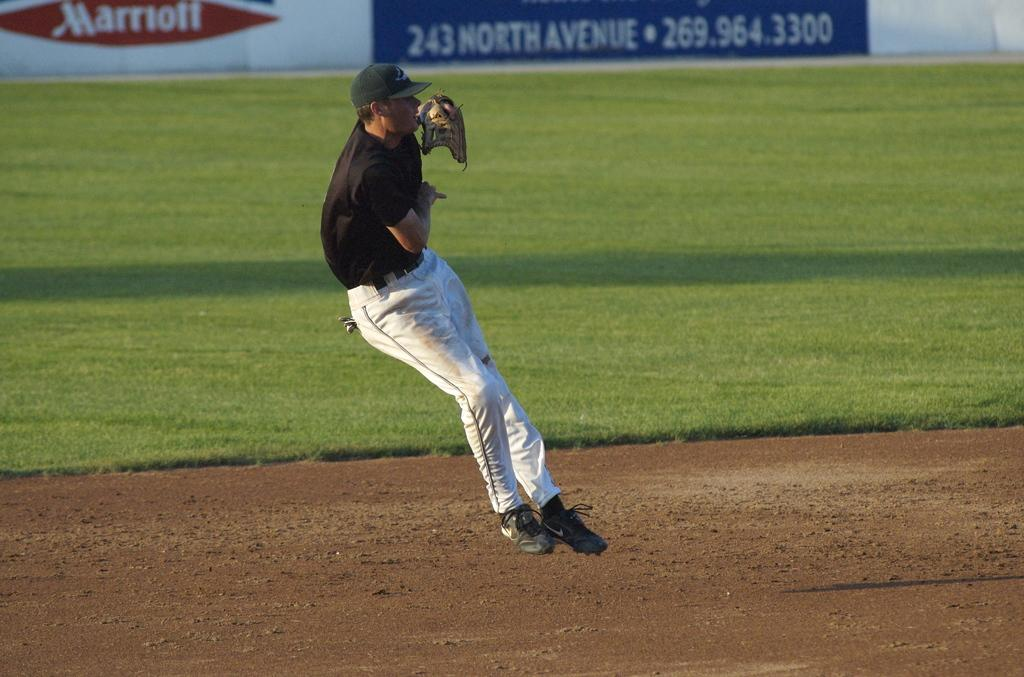<image>
Create a compact narrative representing the image presented. a player that is near a Marriot sign 